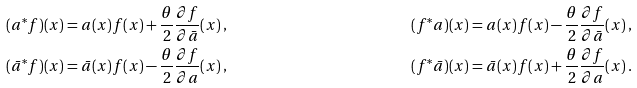<formula> <loc_0><loc_0><loc_500><loc_500>( a ^ { * } f ) ( x ) & = a ( x ) f ( x ) + \frac { \theta } { 2 } \frac { \partial f } { \partial \bar { a } } ( x ) \, , & ( f ^ { * } a ) ( x ) & = a ( x ) f ( x ) - \frac { \theta } { 2 } \frac { \partial f } { \partial \bar { a } } ( x ) \, , \\ ( \bar { a } ^ { * } f ) ( x ) & = \bar { a } ( x ) f ( x ) - \frac { \theta } { 2 } \frac { \partial f } { \partial a } ( x ) \, , & ( f ^ { * } \bar { a } ) ( x ) & = \bar { a } ( x ) f ( x ) + \frac { \theta } { 2 } \frac { \partial f } { \partial a } ( x ) \, .</formula> 